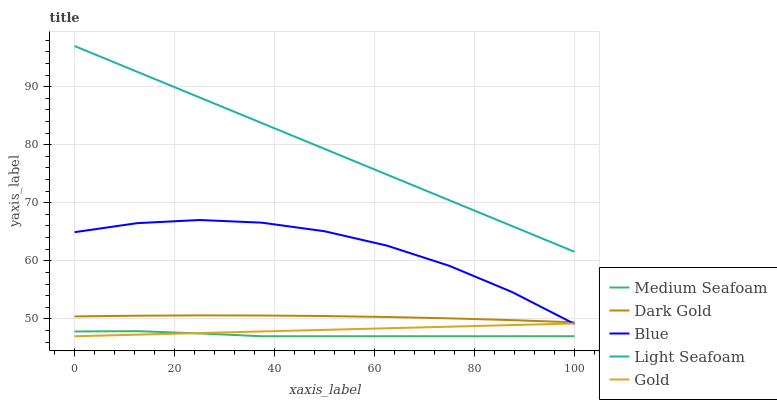Does Medium Seafoam have the minimum area under the curve?
Answer yes or no. Yes. Does Light Seafoam have the maximum area under the curve?
Answer yes or no. Yes. Does Light Seafoam have the minimum area under the curve?
Answer yes or no. No. Does Medium Seafoam have the maximum area under the curve?
Answer yes or no. No. Is Gold the smoothest?
Answer yes or no. Yes. Is Blue the roughest?
Answer yes or no. Yes. Is Light Seafoam the smoothest?
Answer yes or no. No. Is Light Seafoam the roughest?
Answer yes or no. No. Does Light Seafoam have the lowest value?
Answer yes or no. No. Does Medium Seafoam have the highest value?
Answer yes or no. No. Is Gold less than Dark Gold?
Answer yes or no. Yes. Is Light Seafoam greater than Medium Seafoam?
Answer yes or no. Yes. Does Gold intersect Dark Gold?
Answer yes or no. No. 